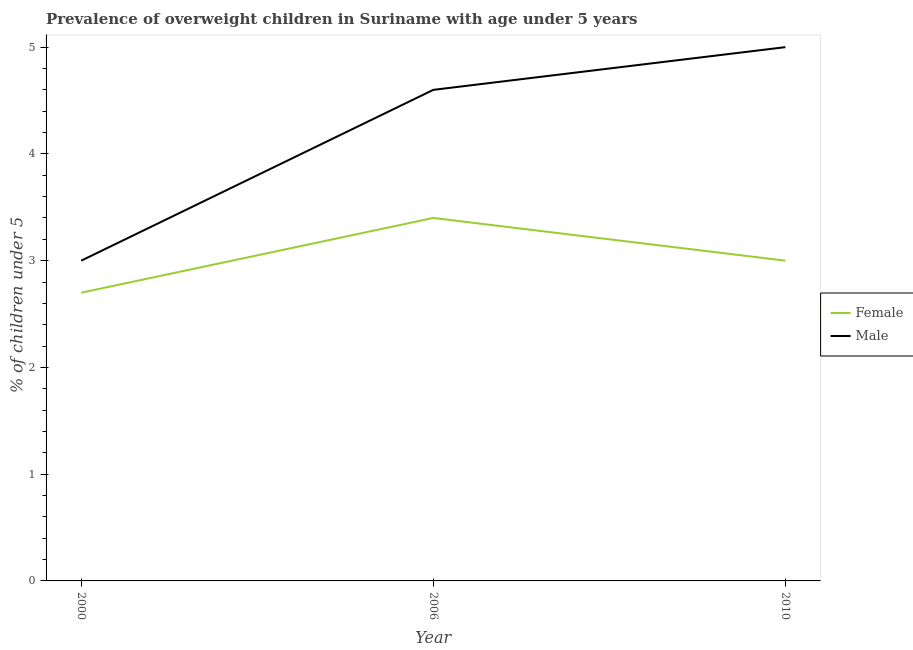How many different coloured lines are there?
Provide a short and direct response. 2. Is the number of lines equal to the number of legend labels?
Give a very brief answer. Yes. Across all years, what is the maximum percentage of obese female children?
Offer a terse response. 3.4. Across all years, what is the minimum percentage of obese female children?
Make the answer very short. 2.7. In which year was the percentage of obese male children maximum?
Make the answer very short. 2010. What is the total percentage of obese female children in the graph?
Offer a very short reply. 9.1. What is the difference between the percentage of obese female children in 2010 and the percentage of obese male children in 2000?
Provide a succinct answer. 0. What is the average percentage of obese male children per year?
Offer a terse response. 4.2. In the year 2006, what is the difference between the percentage of obese female children and percentage of obese male children?
Keep it short and to the point. -1.2. In how many years, is the percentage of obese male children greater than 4.4 %?
Your response must be concise. 2. What is the ratio of the percentage of obese female children in 2000 to that in 2010?
Your answer should be very brief. 0.9. Is the percentage of obese female children in 2000 less than that in 2010?
Give a very brief answer. Yes. What is the difference between the highest and the second highest percentage of obese male children?
Provide a succinct answer. 0.4. What is the difference between the highest and the lowest percentage of obese male children?
Keep it short and to the point. 2. In how many years, is the percentage of obese female children greater than the average percentage of obese female children taken over all years?
Your answer should be compact. 1. Is the percentage of obese male children strictly greater than the percentage of obese female children over the years?
Offer a very short reply. Yes. How many years are there in the graph?
Offer a very short reply. 3. What is the difference between two consecutive major ticks on the Y-axis?
Make the answer very short. 1. How many legend labels are there?
Provide a short and direct response. 2. What is the title of the graph?
Give a very brief answer. Prevalence of overweight children in Suriname with age under 5 years. Does "GDP at market prices" appear as one of the legend labels in the graph?
Keep it short and to the point. No. What is the label or title of the X-axis?
Make the answer very short. Year. What is the label or title of the Y-axis?
Your answer should be compact.  % of children under 5. What is the  % of children under 5 in Female in 2000?
Give a very brief answer. 2.7. What is the  % of children under 5 of Male in 2000?
Give a very brief answer. 3. What is the  % of children under 5 in Female in 2006?
Make the answer very short. 3.4. What is the  % of children under 5 of Male in 2006?
Keep it short and to the point. 4.6. What is the  % of children under 5 of Female in 2010?
Offer a terse response. 3. What is the  % of children under 5 in Male in 2010?
Your answer should be very brief. 5. Across all years, what is the maximum  % of children under 5 in Female?
Your answer should be compact. 3.4. Across all years, what is the maximum  % of children under 5 in Male?
Your answer should be very brief. 5. Across all years, what is the minimum  % of children under 5 in Female?
Your answer should be compact. 2.7. What is the total  % of children under 5 in Female in the graph?
Make the answer very short. 9.1. What is the total  % of children under 5 in Male in the graph?
Give a very brief answer. 12.6. What is the difference between the  % of children under 5 in Female in 2000 and that in 2010?
Make the answer very short. -0.3. What is the difference between the  % of children under 5 in Male in 2000 and that in 2010?
Make the answer very short. -2. What is the difference between the  % of children under 5 of Female in 2006 and that in 2010?
Give a very brief answer. 0.4. What is the difference between the  % of children under 5 in Female in 2000 and the  % of children under 5 in Male in 2010?
Your response must be concise. -2.3. What is the difference between the  % of children under 5 of Female in 2006 and the  % of children under 5 of Male in 2010?
Give a very brief answer. -1.6. What is the average  % of children under 5 of Female per year?
Your response must be concise. 3.03. What is the average  % of children under 5 of Male per year?
Provide a succinct answer. 4.2. In the year 2006, what is the difference between the  % of children under 5 in Female and  % of children under 5 in Male?
Give a very brief answer. -1.2. What is the ratio of the  % of children under 5 in Female in 2000 to that in 2006?
Your answer should be very brief. 0.79. What is the ratio of the  % of children under 5 in Male in 2000 to that in 2006?
Your response must be concise. 0.65. What is the ratio of the  % of children under 5 in Female in 2000 to that in 2010?
Your answer should be very brief. 0.9. What is the ratio of the  % of children under 5 of Male in 2000 to that in 2010?
Ensure brevity in your answer.  0.6. What is the ratio of the  % of children under 5 in Female in 2006 to that in 2010?
Your response must be concise. 1.13. What is the difference between the highest and the second highest  % of children under 5 in Female?
Offer a terse response. 0.4. What is the difference between the highest and the second highest  % of children under 5 in Male?
Make the answer very short. 0.4. 